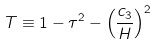<formula> <loc_0><loc_0><loc_500><loc_500>T \equiv 1 - \tau ^ { 2 } - \left ( \frac { c _ { 3 } } { H } \right ) ^ { 2 }</formula> 